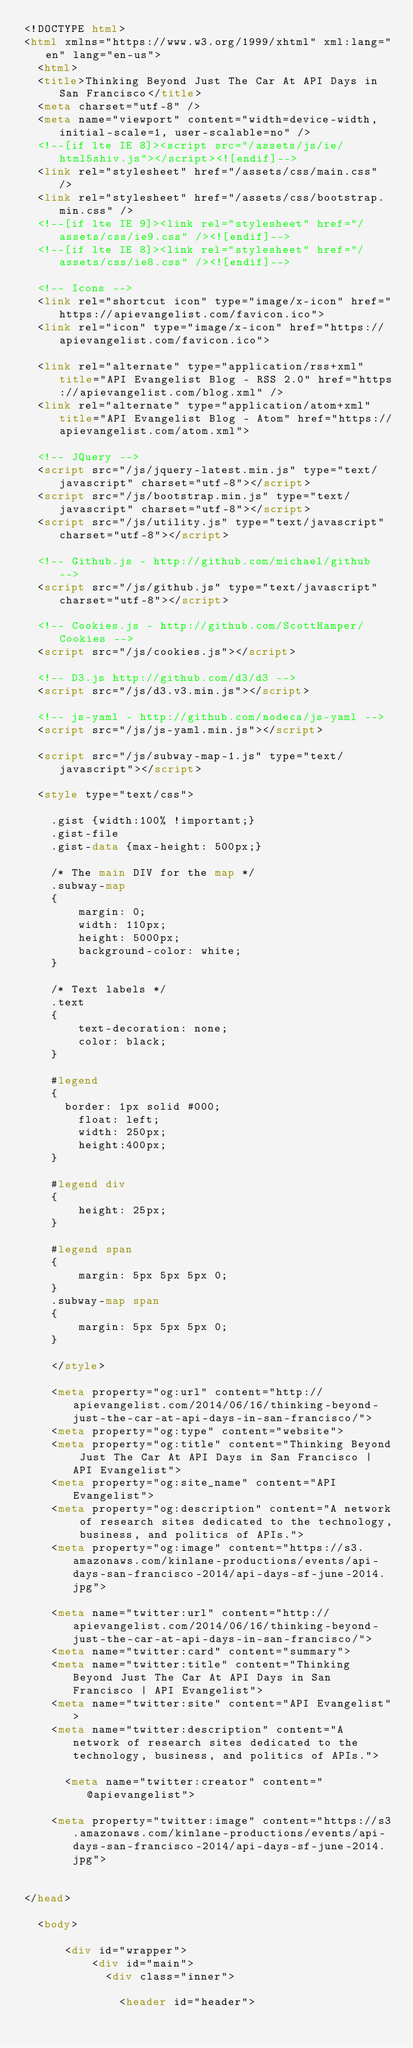<code> <loc_0><loc_0><loc_500><loc_500><_HTML_><!DOCTYPE html>
<html xmlns="https://www.w3.org/1999/xhtml" xml:lang="en" lang="en-us">
  <html>
  <title>Thinking Beyond Just The Car At API Days in San Francisco</title>
  <meta charset="utf-8" />
  <meta name="viewport" content="width=device-width, initial-scale=1, user-scalable=no" />
  <!--[if lte IE 8]><script src="/assets/js/ie/html5shiv.js"></script><![endif]-->
  <link rel="stylesheet" href="/assets/css/main.css" />
  <link rel="stylesheet" href="/assets/css/bootstrap.min.css" />
  <!--[if lte IE 9]><link rel="stylesheet" href="/assets/css/ie9.css" /><![endif]-->
  <!--[if lte IE 8]><link rel="stylesheet" href="/assets/css/ie8.css" /><![endif]-->

  <!-- Icons -->
  <link rel="shortcut icon" type="image/x-icon" href="https://apievangelist.com/favicon.ico">
	<link rel="icon" type="image/x-icon" href="https://apievangelist.com/favicon.ico">

  <link rel="alternate" type="application/rss+xml" title="API Evangelist Blog - RSS 2.0" href="https://apievangelist.com/blog.xml" />
  <link rel="alternate" type="application/atom+xml" title="API Evangelist Blog - Atom" href="https://apievangelist.com/atom.xml">

  <!-- JQuery -->
  <script src="/js/jquery-latest.min.js" type="text/javascript" charset="utf-8"></script>
  <script src="/js/bootstrap.min.js" type="text/javascript" charset="utf-8"></script>
  <script src="/js/utility.js" type="text/javascript" charset="utf-8"></script>

  <!-- Github.js - http://github.com/michael/github -->
  <script src="/js/github.js" type="text/javascript" charset="utf-8"></script>

  <!-- Cookies.js - http://github.com/ScottHamper/Cookies -->
  <script src="/js/cookies.js"></script>

  <!-- D3.js http://github.com/d3/d3 -->
  <script src="/js/d3.v3.min.js"></script>

  <!-- js-yaml - http://github.com/nodeca/js-yaml -->
  <script src="/js/js-yaml.min.js"></script>

  <script src="/js/subway-map-1.js" type="text/javascript"></script>

  <style type="text/css">

    .gist {width:100% !important;}
    .gist-file
    .gist-data {max-height: 500px;}

    /* The main DIV for the map */
    .subway-map
    {
        margin: 0;
        width: 110px;
        height: 5000px;
        background-color: white;
    }

    /* Text labels */
    .text
    {
        text-decoration: none;
        color: black;
    }

    #legend
    {
    	border: 1px solid #000;
        float: left;
        width: 250px;
        height:400px;
    }

    #legend div
    {
        height: 25px;
    }

    #legend span
    {
        margin: 5px 5px 5px 0;
    }
    .subway-map span
    {
        margin: 5px 5px 5px 0;
    }

    </style>

    <meta property="og:url" content="http://apievangelist.com/2014/06/16/thinking-beyond-just-the-car-at-api-days-in-san-francisco/">
    <meta property="og:type" content="website">
    <meta property="og:title" content="Thinking Beyond Just The Car At API Days in San Francisco | API Evangelist">
    <meta property="og:site_name" content="API Evangelist">
    <meta property="og:description" content="A network of research sites dedicated to the technology, business, and politics of APIs.">
    <meta property="og:image" content="https://s3.amazonaws.com/kinlane-productions/events/api-days-san-francisco-2014/api-days-sf-june-2014.jpg">

    <meta name="twitter:url" content="http://apievangelist.com/2014/06/16/thinking-beyond-just-the-car-at-api-days-in-san-francisco/">
    <meta name="twitter:card" content="summary">
    <meta name="twitter:title" content="Thinking Beyond Just The Car At API Days in San Francisco | API Evangelist">
    <meta name="twitter:site" content="API Evangelist">
    <meta name="twitter:description" content="A network of research sites dedicated to the technology, business, and politics of APIs.">
    
      <meta name="twitter:creator" content="@apievangelist">
    
    <meta property="twitter:image" content="https://s3.amazonaws.com/kinlane-productions/events/api-days-san-francisco-2014/api-days-sf-june-2014.jpg">


</head>

  <body>

			<div id="wrapper">
					<div id="main">
						<div class="inner">

              <header id="header"></code> 